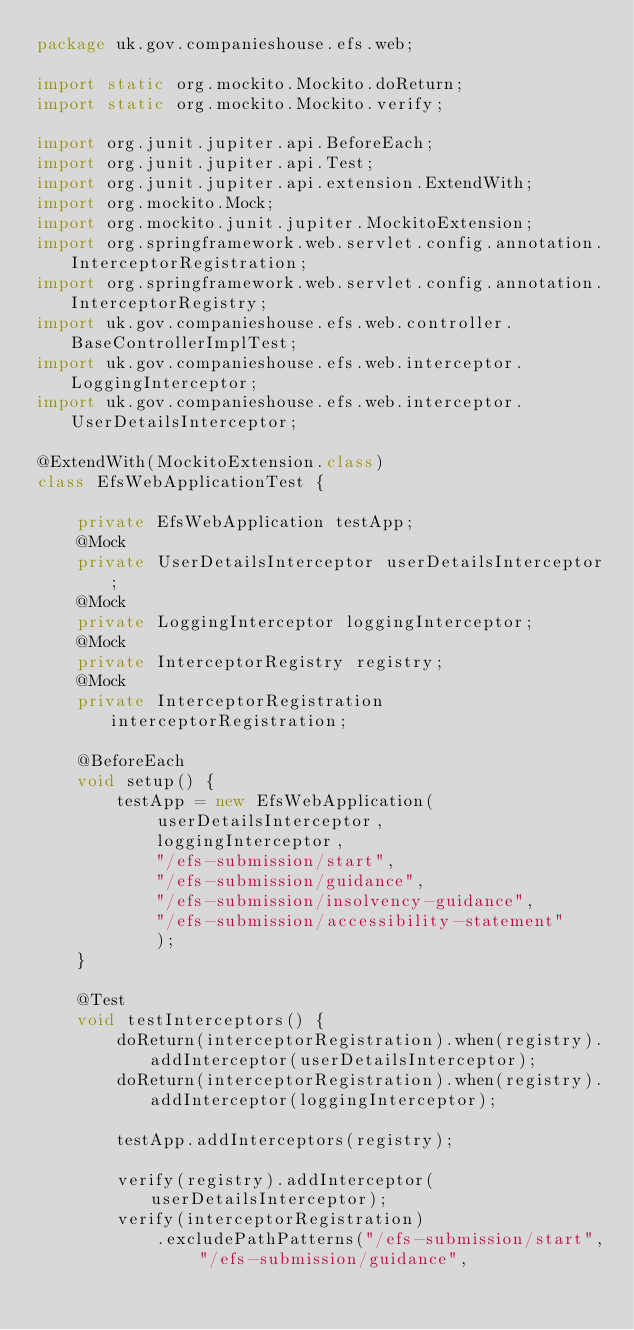<code> <loc_0><loc_0><loc_500><loc_500><_Java_>package uk.gov.companieshouse.efs.web;

import static org.mockito.Mockito.doReturn;
import static org.mockito.Mockito.verify;

import org.junit.jupiter.api.BeforeEach;
import org.junit.jupiter.api.Test;
import org.junit.jupiter.api.extension.ExtendWith;
import org.mockito.Mock;
import org.mockito.junit.jupiter.MockitoExtension;
import org.springframework.web.servlet.config.annotation.InterceptorRegistration;
import org.springframework.web.servlet.config.annotation.InterceptorRegistry;
import uk.gov.companieshouse.efs.web.controller.BaseControllerImplTest;
import uk.gov.companieshouse.efs.web.interceptor.LoggingInterceptor;
import uk.gov.companieshouse.efs.web.interceptor.UserDetailsInterceptor;

@ExtendWith(MockitoExtension.class)
class EfsWebApplicationTest {

    private EfsWebApplication testApp;
    @Mock
    private UserDetailsInterceptor userDetailsInterceptor;
    @Mock
    private LoggingInterceptor loggingInterceptor;
    @Mock
    private InterceptorRegistry registry;
    @Mock
    private InterceptorRegistration interceptorRegistration;

    @BeforeEach
    void setup() {
        testApp = new EfsWebApplication(
            userDetailsInterceptor,
            loggingInterceptor,
            "/efs-submission/start",
            "/efs-submission/guidance",
            "/efs-submission/insolvency-guidance",
            "/efs-submission/accessibility-statement"
            );
    }

    @Test
    void testInterceptors() {
        doReturn(interceptorRegistration).when(registry).addInterceptor(userDetailsInterceptor);
        doReturn(interceptorRegistration).when(registry).addInterceptor(loggingInterceptor);

        testApp.addInterceptors(registry);

        verify(registry).addInterceptor(userDetailsInterceptor);
        verify(interceptorRegistration)
            .excludePathPatterns("/efs-submission/start", "/efs-submission/guidance",</code> 